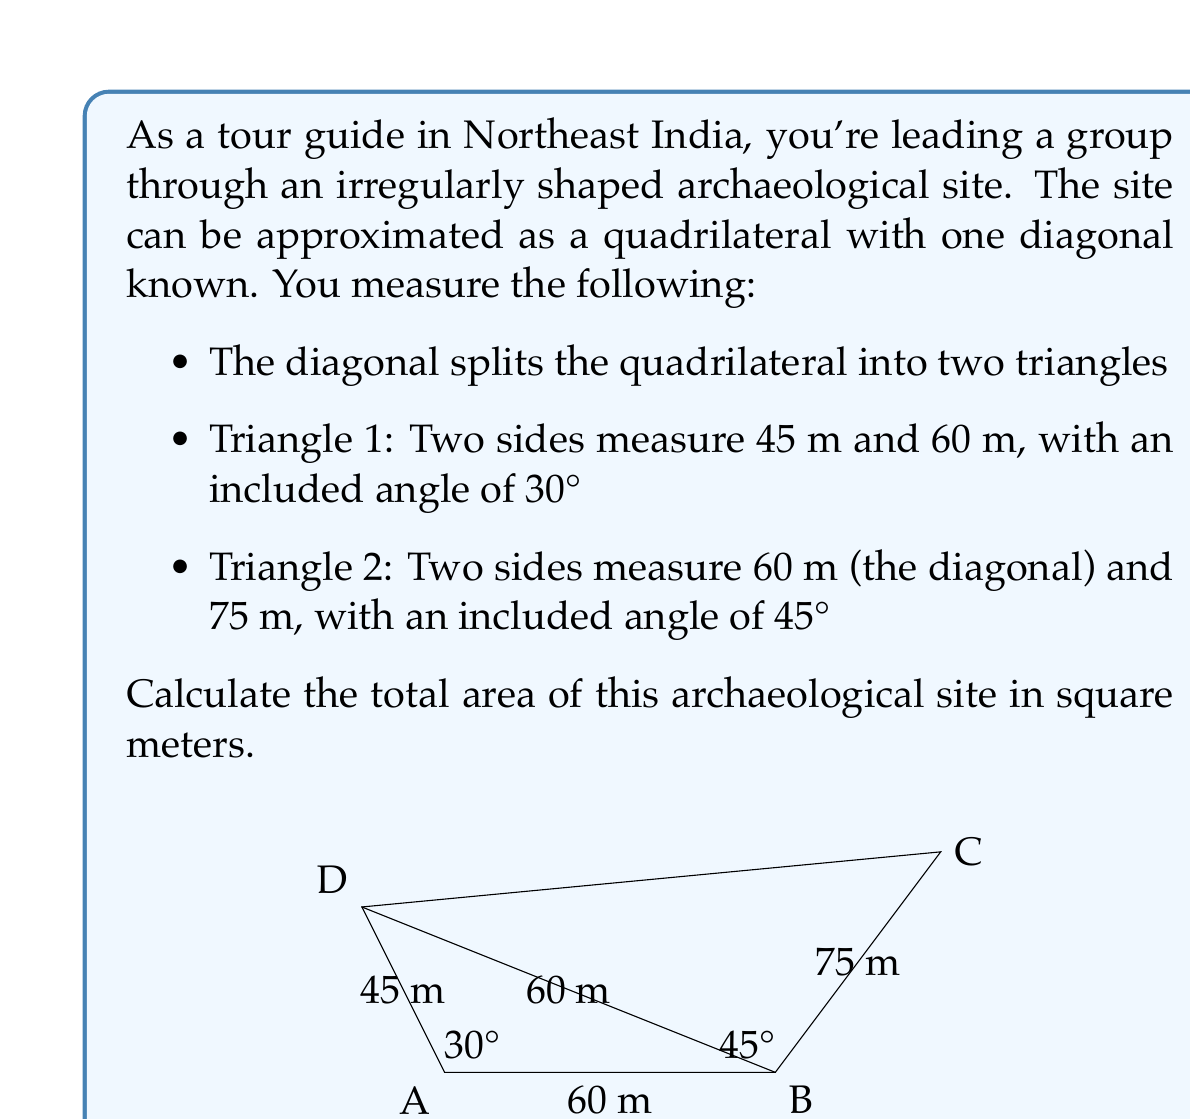Show me your answer to this math problem. To solve this problem, we'll calculate the areas of the two triangles separately and then add them together.

For Triangle 1 (ABD):
We can use the formula for the area of a triangle given two sides and the included angle:
$$ \text{Area}_1 = \frac{1}{2} \cdot a \cdot b \cdot \sin(C) $$
Where $a = 45$ m, $b = 60$ m, and $C = 30°$

$$ \text{Area}_1 = \frac{1}{2} \cdot 45 \cdot 60 \cdot \sin(30°) $$
$$ = \frac{1}{2} \cdot 45 \cdot 60 \cdot 0.5 $$
$$ = 675 \text{ m}^2 $$

For Triangle 2 (BCD):
We use the same formula:
$$ \text{Area}_2 = \frac{1}{2} \cdot a \cdot b \cdot \sin(C) $$
Where $a = 60$ m, $b = 75$ m, and $C = 45°$

$$ \text{Area}_2 = \frac{1}{2} \cdot 60 \cdot 75 \cdot \sin(45°) $$
$$ = \frac{1}{2} \cdot 60 \cdot 75 \cdot \frac{\sqrt{2}}{2} $$
$$ = 1590.99 \text{ m}^2 $$

The total area of the archaeological site is the sum of these two areas:
$$ \text{Total Area} = \text{Area}_1 + \text{Area}_2 $$
$$ = 675 + 1590.99 $$
$$ = 2265.99 \text{ m}^2 $$
Answer: The total area of the archaeological site is approximately 2266 m². 